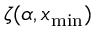<formula> <loc_0><loc_0><loc_500><loc_500>\zeta ( \alpha , x _ { \min } )</formula> 